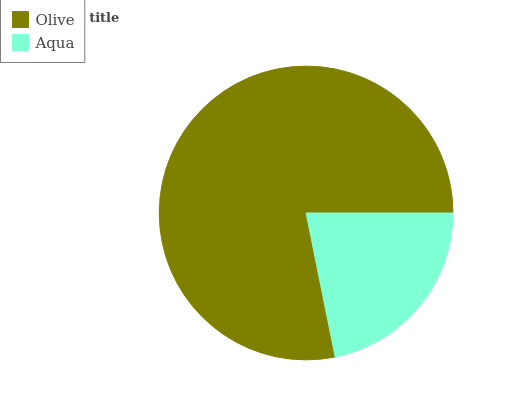Is Aqua the minimum?
Answer yes or no. Yes. Is Olive the maximum?
Answer yes or no. Yes. Is Aqua the maximum?
Answer yes or no. No. Is Olive greater than Aqua?
Answer yes or no. Yes. Is Aqua less than Olive?
Answer yes or no. Yes. Is Aqua greater than Olive?
Answer yes or no. No. Is Olive less than Aqua?
Answer yes or no. No. Is Olive the high median?
Answer yes or no. Yes. Is Aqua the low median?
Answer yes or no. Yes. Is Aqua the high median?
Answer yes or no. No. Is Olive the low median?
Answer yes or no. No. 